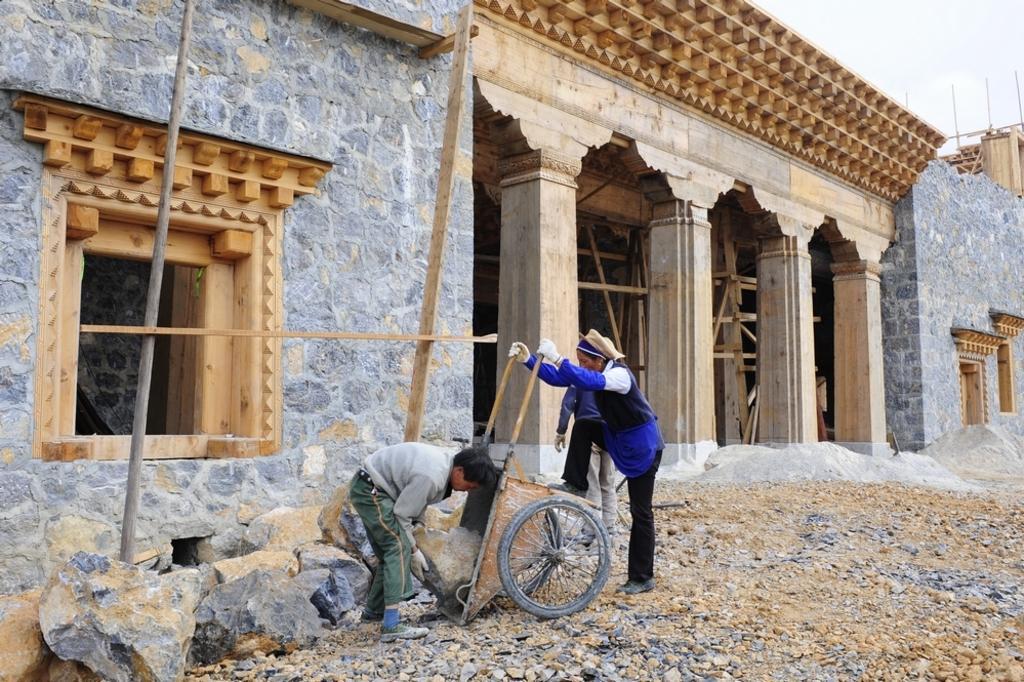How would you summarize this image in a sentence or two? In this image we can see a cart and two people. In the background, we can see buildings and bamboos. At the bottom of the image, we can see the stones, cement and rocks. We can see the sky in the right top of the image. 